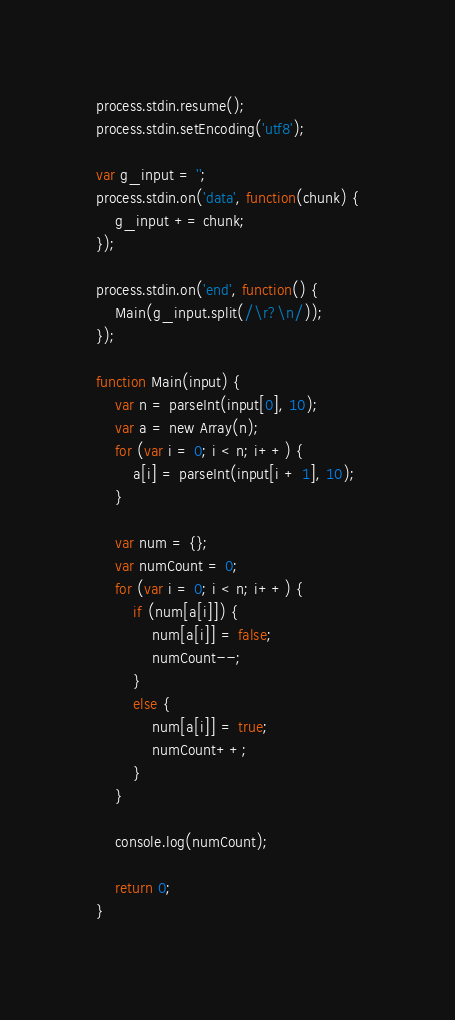Convert code to text. <code><loc_0><loc_0><loc_500><loc_500><_JavaScript_>process.stdin.resume();
process.stdin.setEncoding('utf8');

var g_input = '';
process.stdin.on('data', function(chunk) {
    g_input += chunk;
});

process.stdin.on('end', function() {
    Main(g_input.split(/\r?\n/));
});

function Main(input) {
    var n = parseInt(input[0], 10);
    var a = new Array(n);
    for (var i = 0; i < n; i++) {
        a[i] = parseInt(input[i + 1], 10);
    }

    var num = {};
    var numCount = 0;
    for (var i = 0; i < n; i++) {
        if (num[a[i]]) {
            num[a[i]] = false;
            numCount--;
        }
        else {
            num[a[i]] = true;
            numCount++;
        }
    }

    console.log(numCount);

    return 0;
}

</code> 